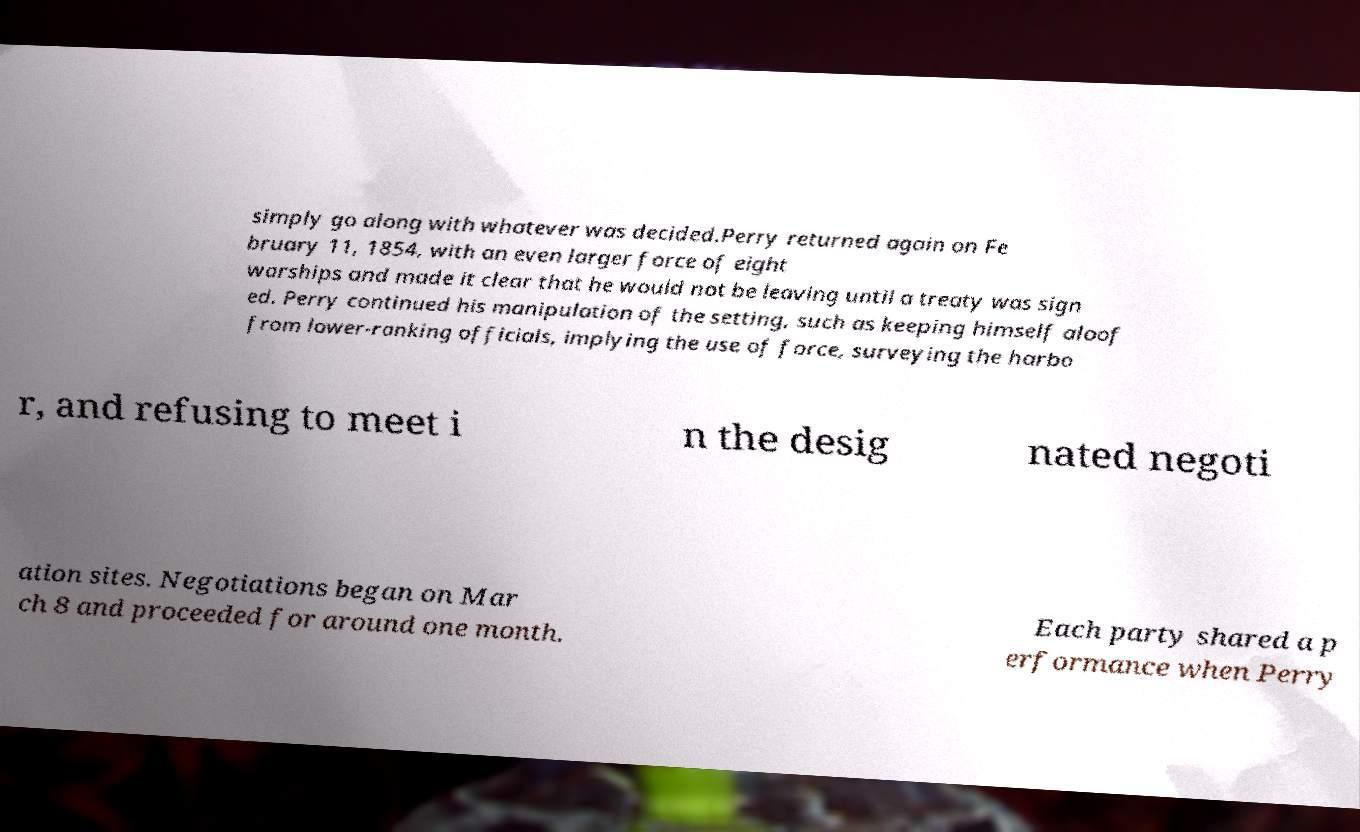What messages or text are displayed in this image? I need them in a readable, typed format. simply go along with whatever was decided.Perry returned again on Fe bruary 11, 1854, with an even larger force of eight warships and made it clear that he would not be leaving until a treaty was sign ed. Perry continued his manipulation of the setting, such as keeping himself aloof from lower-ranking officials, implying the use of force, surveying the harbo r, and refusing to meet i n the desig nated negoti ation sites. Negotiations began on Mar ch 8 and proceeded for around one month. Each party shared a p erformance when Perry 